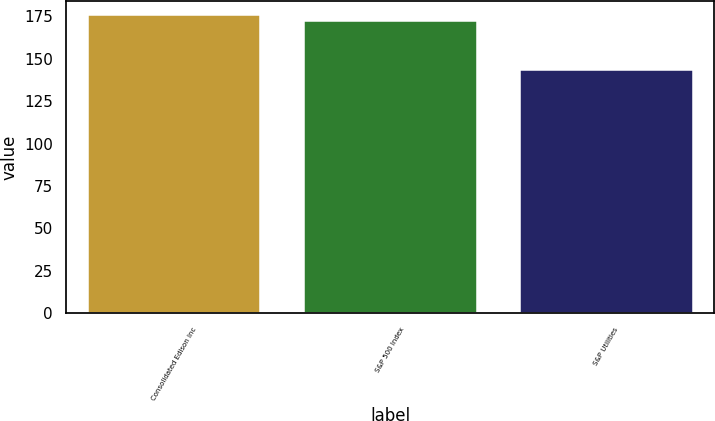<chart> <loc_0><loc_0><loc_500><loc_500><bar_chart><fcel>Consolidated Edison Inc<fcel>S&P 500 Index<fcel>S&P Utilities<nl><fcel>175.41<fcel>172.37<fcel>143.35<nl></chart> 